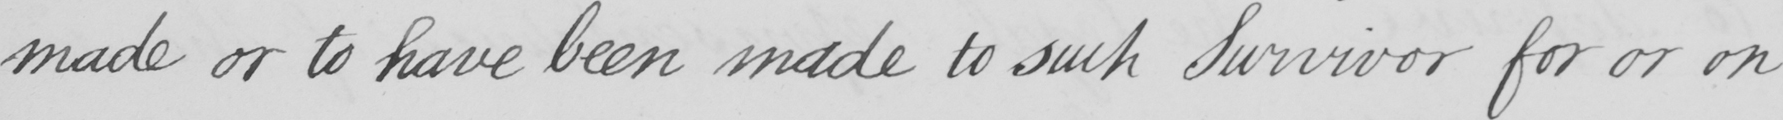Please transcribe the handwritten text in this image. made or to have been made to such Survivor for or on 